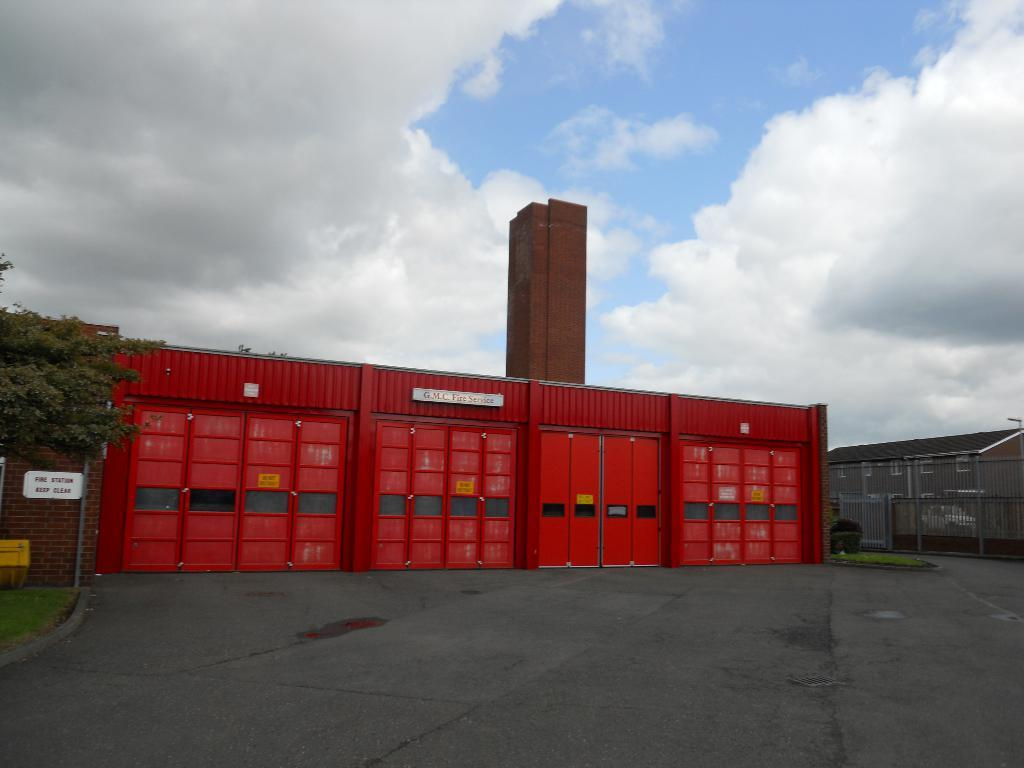What is the main structure visible in the image? There is a big go-down in the image. What is located in front of the go-down? There is a road in front of the go-down. Are there any natural elements visible near the road? Yes, there is a tree near the road. What can be seen in the sky in the image? There are clouds visible in the sky. What type of apparatus is being used by the animal in the image? There is no animal or apparatus present in the image. 